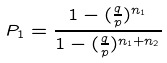Convert formula to latex. <formula><loc_0><loc_0><loc_500><loc_500>P _ { 1 } = \frac { 1 - ( \frac { q } { p } ) ^ { n _ { 1 } } } { 1 - ( \frac { q } { p } ) ^ { n _ { 1 } + n _ { 2 } } }</formula> 